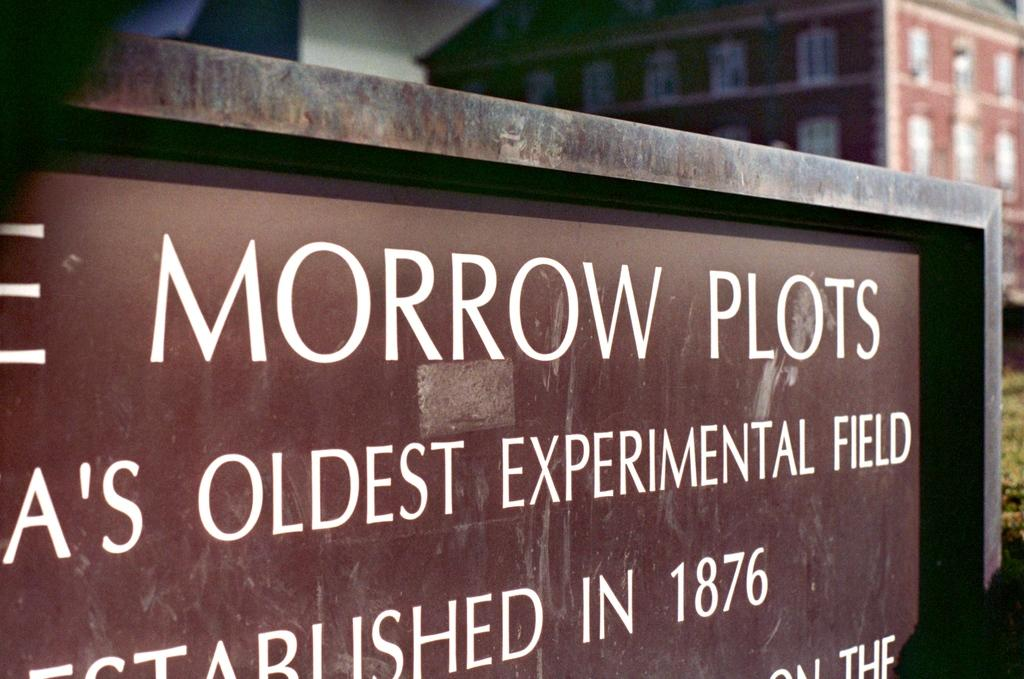What type of structure is visible in the image? There is a building in the image. What can be seen in the foreground of the image? There is text on a board in the foreground of the image. What type of vegetation is on the right side of the image? There appears to be a tree on the right side of the image. What type of feeling does the hose in the image convey? There is no hose present in the image, so it cannot convey any feelings. 